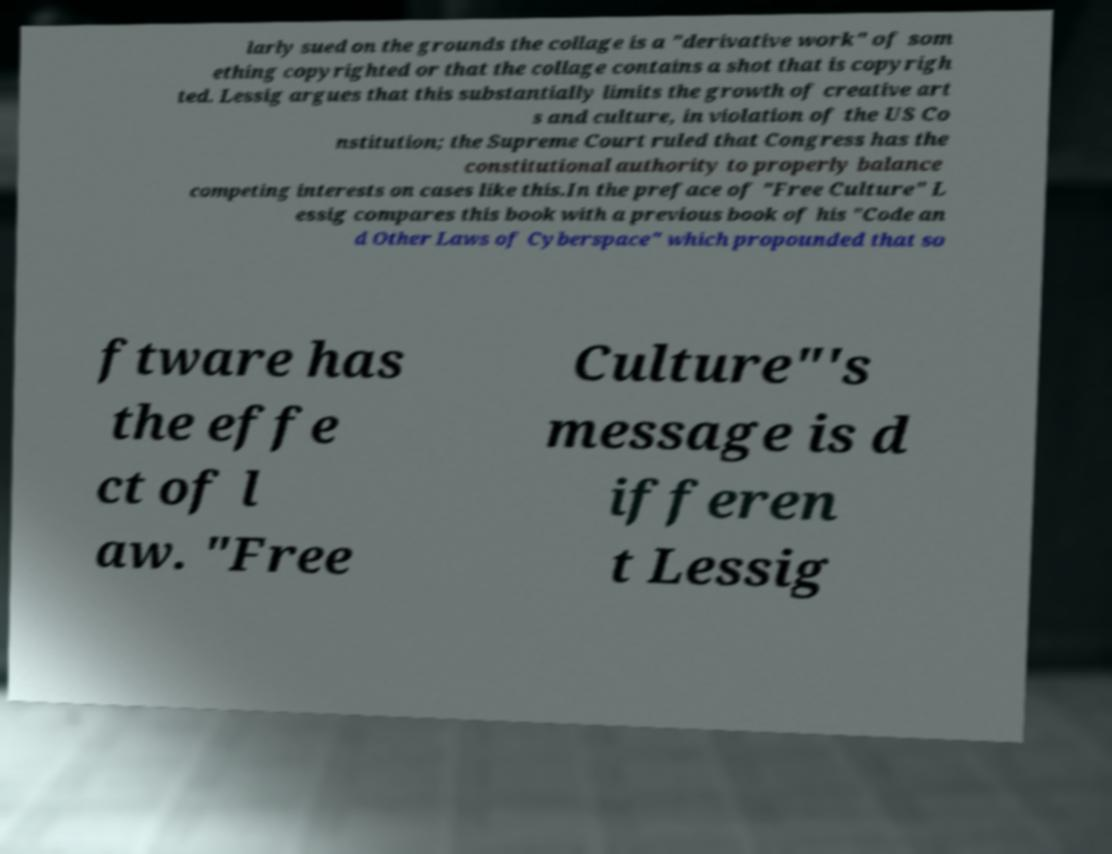Can you accurately transcribe the text from the provided image for me? larly sued on the grounds the collage is a "derivative work" of som ething copyrighted or that the collage contains a shot that is copyrigh ted. Lessig argues that this substantially limits the growth of creative art s and culture, in violation of the US Co nstitution; the Supreme Court ruled that Congress has the constitutional authority to properly balance competing interests on cases like this.In the preface of "Free Culture" L essig compares this book with a previous book of his "Code an d Other Laws of Cyberspace" which propounded that so ftware has the effe ct of l aw. "Free Culture"'s message is d ifferen t Lessig 